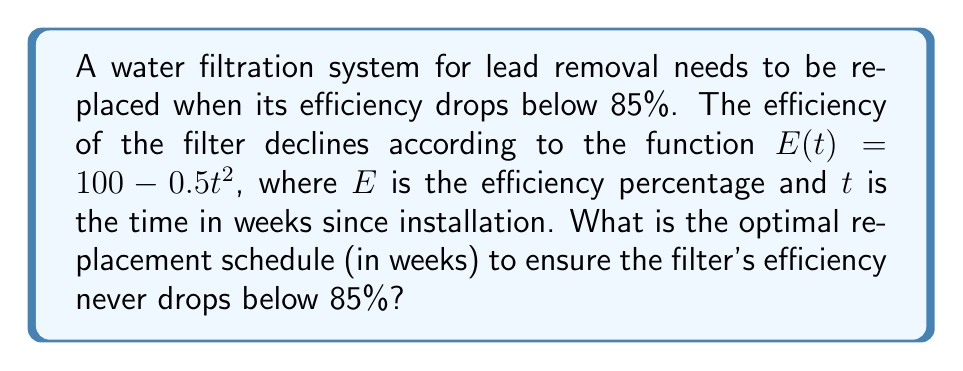Teach me how to tackle this problem. To solve this problem, we need to find the time $t$ when the efficiency $E(t)$ reaches 85%. We can do this by setting up and solving an equation:

1) Set up the equation:
   $E(t) = 85$
   $100 - 0.5t^2 = 85$

2) Rearrange the equation:
   $-0.5t^2 = -15$
   $0.5t^2 = 15$

3) Solve for $t$:
   $t^2 = 30$
   $t = \sqrt{30} \approx 5.477$ weeks

4) Since we can't replace the filter partially through a week, we need to round down to ensure the efficiency never drops below 85%. 

5) Therefore, the optimal replacement schedule is every 5 weeks.

We can verify this:
At 5 weeks: $E(5) = 100 - 0.5(5^2) = 87.5\%$
At 6 weeks: $E(6) = 100 - 0.5(6^2) = 82\%$

This confirms that replacing every 5 weeks keeps the efficiency above 85%, while waiting 6 weeks would allow it to drop below 85%.
Answer: The optimal replacement schedule is every 5 weeks. 